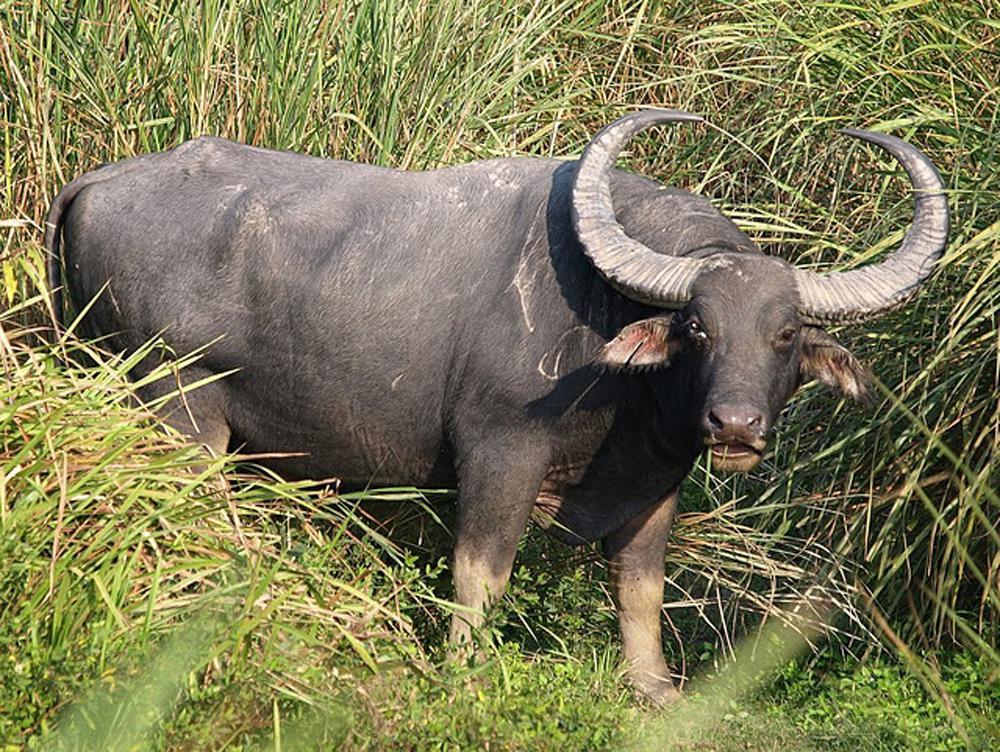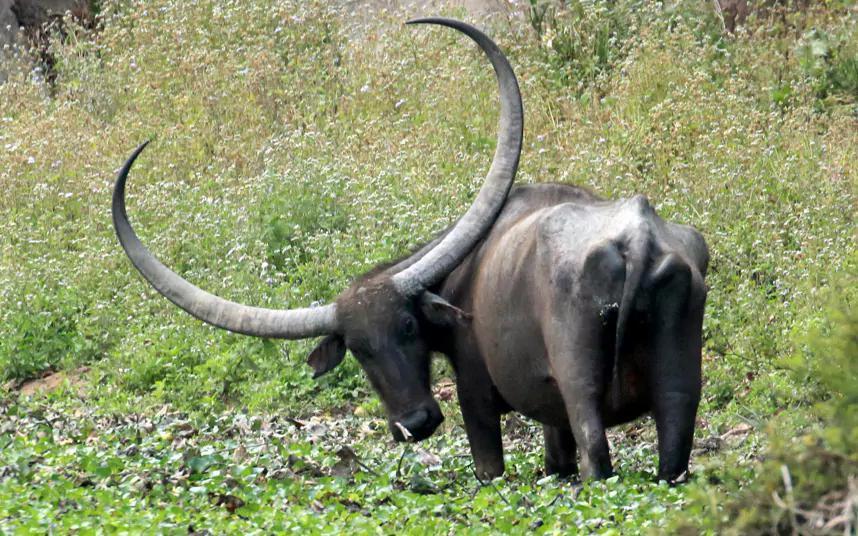The first image is the image on the left, the second image is the image on the right. Given the left and right images, does the statement "There are 3 water buffalos shown." hold true? Answer yes or no. No. 